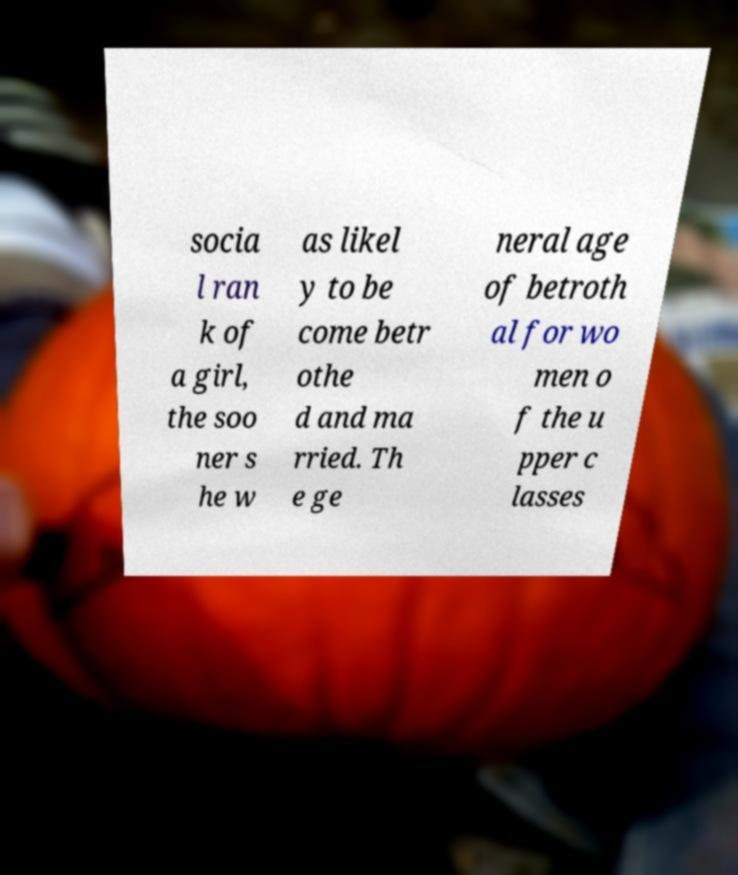Can you accurately transcribe the text from the provided image for me? socia l ran k of a girl, the soo ner s he w as likel y to be come betr othe d and ma rried. Th e ge neral age of betroth al for wo men o f the u pper c lasses 